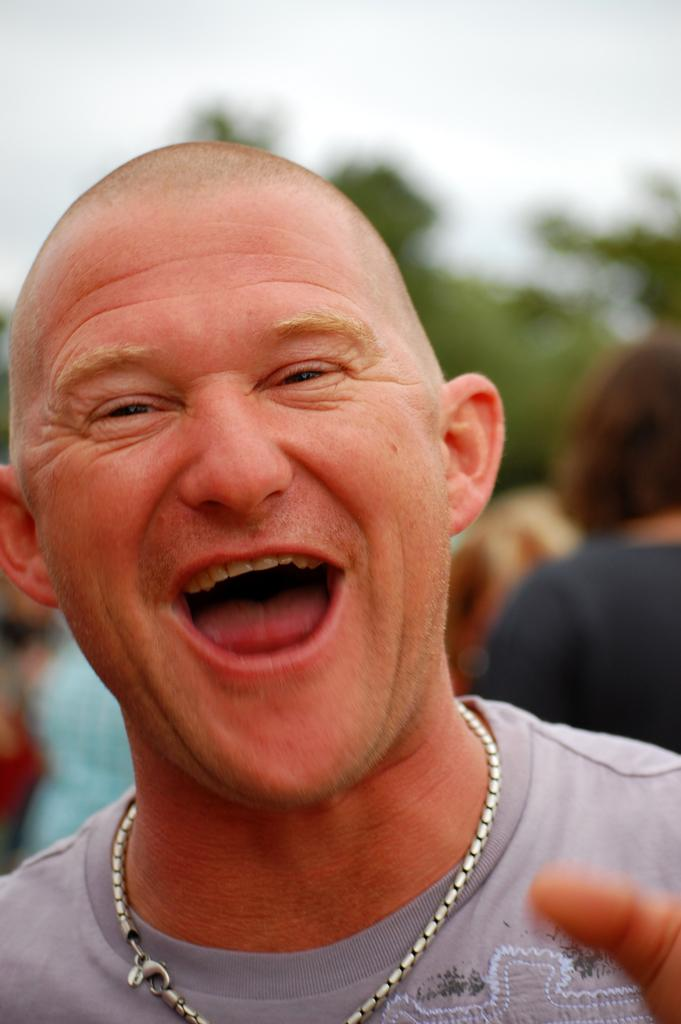Who is present in the image? There is a man in the image. What is the man doing in the image? The man is smiling in the image. Are there any other people in the image besides the man? Yes, there are people behind the man in the image. What can be seen in the background of the image? Trees and the sky are visible in the image. What type of breakfast is the man eating in the image? There is no breakfast present in the image; it only shows a man smiling with people behind him, trees, and the sky in the background. 